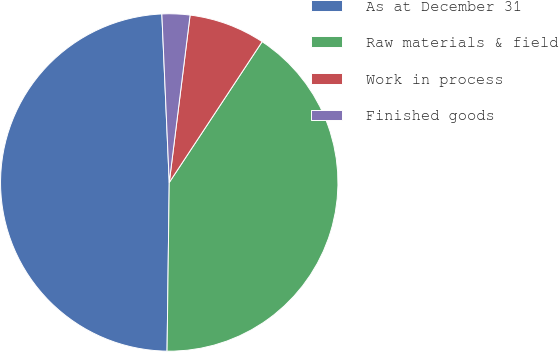<chart> <loc_0><loc_0><loc_500><loc_500><pie_chart><fcel>As at December 31<fcel>Raw materials & field<fcel>Work in process<fcel>Finished goods<nl><fcel>49.1%<fcel>40.93%<fcel>7.31%<fcel>2.67%<nl></chart> 